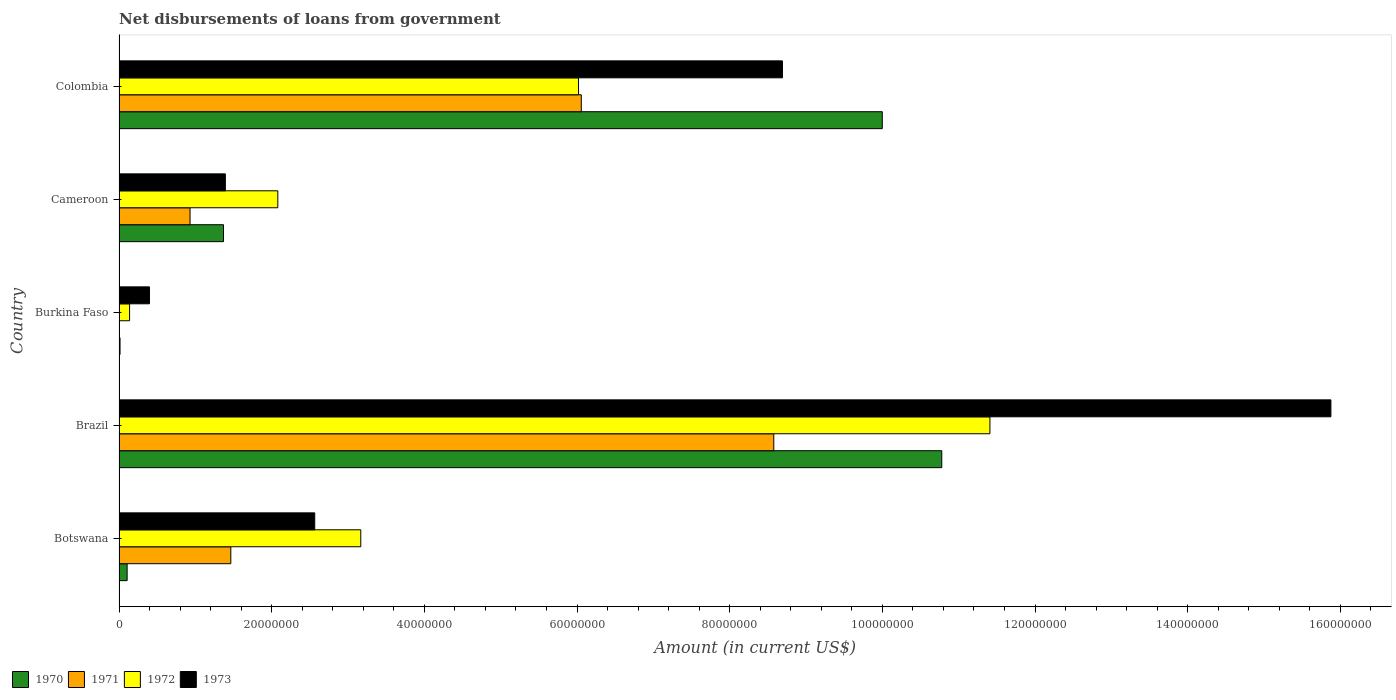How many different coloured bars are there?
Offer a terse response. 4. Are the number of bars per tick equal to the number of legend labels?
Make the answer very short. No. Are the number of bars on each tick of the Y-axis equal?
Your answer should be compact. No. How many bars are there on the 4th tick from the top?
Provide a succinct answer. 4. How many bars are there on the 4th tick from the bottom?
Make the answer very short. 4. What is the label of the 5th group of bars from the top?
Provide a short and direct response. Botswana. In how many cases, is the number of bars for a given country not equal to the number of legend labels?
Your answer should be very brief. 1. What is the amount of loan disbursed from government in 1972 in Burkina Faso?
Give a very brief answer. 1.38e+06. Across all countries, what is the maximum amount of loan disbursed from government in 1973?
Make the answer very short. 1.59e+08. Across all countries, what is the minimum amount of loan disbursed from government in 1972?
Give a very brief answer. 1.38e+06. In which country was the amount of loan disbursed from government in 1972 maximum?
Offer a very short reply. Brazil. What is the total amount of loan disbursed from government in 1973 in the graph?
Keep it short and to the point. 2.89e+08. What is the difference between the amount of loan disbursed from government in 1971 in Botswana and that in Cameroon?
Your answer should be very brief. 5.34e+06. What is the difference between the amount of loan disbursed from government in 1972 in Colombia and the amount of loan disbursed from government in 1970 in Brazil?
Your response must be concise. -4.76e+07. What is the average amount of loan disbursed from government in 1972 per country?
Make the answer very short. 4.56e+07. What is the difference between the amount of loan disbursed from government in 1971 and amount of loan disbursed from government in 1970 in Cameroon?
Provide a succinct answer. -4.38e+06. What is the ratio of the amount of loan disbursed from government in 1972 in Brazil to that in Cameroon?
Give a very brief answer. 5.49. Is the difference between the amount of loan disbursed from government in 1971 in Cameroon and Colombia greater than the difference between the amount of loan disbursed from government in 1970 in Cameroon and Colombia?
Offer a very short reply. Yes. What is the difference between the highest and the second highest amount of loan disbursed from government in 1972?
Your answer should be very brief. 5.39e+07. What is the difference between the highest and the lowest amount of loan disbursed from government in 1971?
Keep it short and to the point. 8.58e+07. In how many countries, is the amount of loan disbursed from government in 1973 greater than the average amount of loan disbursed from government in 1973 taken over all countries?
Offer a very short reply. 2. Is the sum of the amount of loan disbursed from government in 1972 in Brazil and Cameroon greater than the maximum amount of loan disbursed from government in 1973 across all countries?
Provide a succinct answer. No. Is it the case that in every country, the sum of the amount of loan disbursed from government in 1972 and amount of loan disbursed from government in 1970 is greater than the sum of amount of loan disbursed from government in 1971 and amount of loan disbursed from government in 1973?
Provide a short and direct response. No. Is it the case that in every country, the sum of the amount of loan disbursed from government in 1973 and amount of loan disbursed from government in 1970 is greater than the amount of loan disbursed from government in 1971?
Ensure brevity in your answer.  Yes. How many bars are there?
Give a very brief answer. 19. Are all the bars in the graph horizontal?
Keep it short and to the point. Yes. Are the values on the major ticks of X-axis written in scientific E-notation?
Give a very brief answer. No. Does the graph contain any zero values?
Your answer should be compact. Yes. How are the legend labels stacked?
Your response must be concise. Horizontal. What is the title of the graph?
Keep it short and to the point. Net disbursements of loans from government. What is the label or title of the Y-axis?
Offer a terse response. Country. What is the Amount (in current US$) in 1970 in Botswana?
Ensure brevity in your answer.  1.06e+06. What is the Amount (in current US$) in 1971 in Botswana?
Your response must be concise. 1.46e+07. What is the Amount (in current US$) in 1972 in Botswana?
Provide a succinct answer. 3.17e+07. What is the Amount (in current US$) of 1973 in Botswana?
Offer a very short reply. 2.56e+07. What is the Amount (in current US$) in 1970 in Brazil?
Offer a terse response. 1.08e+08. What is the Amount (in current US$) of 1971 in Brazil?
Your answer should be very brief. 8.58e+07. What is the Amount (in current US$) of 1972 in Brazil?
Keep it short and to the point. 1.14e+08. What is the Amount (in current US$) of 1973 in Brazil?
Provide a succinct answer. 1.59e+08. What is the Amount (in current US$) of 1970 in Burkina Faso?
Ensure brevity in your answer.  1.29e+05. What is the Amount (in current US$) of 1971 in Burkina Faso?
Offer a terse response. 0. What is the Amount (in current US$) in 1972 in Burkina Faso?
Give a very brief answer. 1.38e+06. What is the Amount (in current US$) in 1973 in Burkina Faso?
Your answer should be compact. 3.98e+06. What is the Amount (in current US$) of 1970 in Cameroon?
Ensure brevity in your answer.  1.37e+07. What is the Amount (in current US$) of 1971 in Cameroon?
Make the answer very short. 9.30e+06. What is the Amount (in current US$) of 1972 in Cameroon?
Your response must be concise. 2.08e+07. What is the Amount (in current US$) in 1973 in Cameroon?
Offer a very short reply. 1.39e+07. What is the Amount (in current US$) in 1970 in Colombia?
Your response must be concise. 1.00e+08. What is the Amount (in current US$) of 1971 in Colombia?
Offer a very short reply. 6.06e+07. What is the Amount (in current US$) in 1972 in Colombia?
Offer a terse response. 6.02e+07. What is the Amount (in current US$) of 1973 in Colombia?
Make the answer very short. 8.69e+07. Across all countries, what is the maximum Amount (in current US$) of 1970?
Your response must be concise. 1.08e+08. Across all countries, what is the maximum Amount (in current US$) in 1971?
Provide a short and direct response. 8.58e+07. Across all countries, what is the maximum Amount (in current US$) in 1972?
Ensure brevity in your answer.  1.14e+08. Across all countries, what is the maximum Amount (in current US$) of 1973?
Your response must be concise. 1.59e+08. Across all countries, what is the minimum Amount (in current US$) of 1970?
Keep it short and to the point. 1.29e+05. Across all countries, what is the minimum Amount (in current US$) of 1972?
Your answer should be compact. 1.38e+06. Across all countries, what is the minimum Amount (in current US$) in 1973?
Provide a short and direct response. 3.98e+06. What is the total Amount (in current US$) in 1970 in the graph?
Make the answer very short. 2.23e+08. What is the total Amount (in current US$) in 1971 in the graph?
Your answer should be very brief. 1.70e+08. What is the total Amount (in current US$) in 1972 in the graph?
Give a very brief answer. 2.28e+08. What is the total Amount (in current US$) in 1973 in the graph?
Make the answer very short. 2.89e+08. What is the difference between the Amount (in current US$) in 1970 in Botswana and that in Brazil?
Your response must be concise. -1.07e+08. What is the difference between the Amount (in current US$) of 1971 in Botswana and that in Brazil?
Ensure brevity in your answer.  -7.11e+07. What is the difference between the Amount (in current US$) of 1972 in Botswana and that in Brazil?
Your answer should be compact. -8.24e+07. What is the difference between the Amount (in current US$) of 1973 in Botswana and that in Brazil?
Keep it short and to the point. -1.33e+08. What is the difference between the Amount (in current US$) in 1970 in Botswana and that in Burkina Faso?
Make the answer very short. 9.28e+05. What is the difference between the Amount (in current US$) in 1972 in Botswana and that in Burkina Faso?
Give a very brief answer. 3.03e+07. What is the difference between the Amount (in current US$) of 1973 in Botswana and that in Burkina Faso?
Your answer should be compact. 2.17e+07. What is the difference between the Amount (in current US$) of 1970 in Botswana and that in Cameroon?
Offer a terse response. -1.26e+07. What is the difference between the Amount (in current US$) in 1971 in Botswana and that in Cameroon?
Provide a succinct answer. 5.34e+06. What is the difference between the Amount (in current US$) of 1972 in Botswana and that in Cameroon?
Your answer should be compact. 1.09e+07. What is the difference between the Amount (in current US$) in 1973 in Botswana and that in Cameroon?
Provide a succinct answer. 1.17e+07. What is the difference between the Amount (in current US$) of 1970 in Botswana and that in Colombia?
Give a very brief answer. -9.89e+07. What is the difference between the Amount (in current US$) in 1971 in Botswana and that in Colombia?
Provide a succinct answer. -4.59e+07. What is the difference between the Amount (in current US$) of 1972 in Botswana and that in Colombia?
Your answer should be very brief. -2.85e+07. What is the difference between the Amount (in current US$) in 1973 in Botswana and that in Colombia?
Make the answer very short. -6.13e+07. What is the difference between the Amount (in current US$) in 1970 in Brazil and that in Burkina Faso?
Keep it short and to the point. 1.08e+08. What is the difference between the Amount (in current US$) in 1972 in Brazil and that in Burkina Faso?
Provide a succinct answer. 1.13e+08. What is the difference between the Amount (in current US$) in 1973 in Brazil and that in Burkina Faso?
Provide a short and direct response. 1.55e+08. What is the difference between the Amount (in current US$) in 1970 in Brazil and that in Cameroon?
Offer a terse response. 9.41e+07. What is the difference between the Amount (in current US$) in 1971 in Brazil and that in Cameroon?
Your answer should be very brief. 7.65e+07. What is the difference between the Amount (in current US$) in 1972 in Brazil and that in Cameroon?
Offer a terse response. 9.33e+07. What is the difference between the Amount (in current US$) of 1973 in Brazil and that in Cameroon?
Keep it short and to the point. 1.45e+08. What is the difference between the Amount (in current US$) in 1970 in Brazil and that in Colombia?
Provide a short and direct response. 7.79e+06. What is the difference between the Amount (in current US$) in 1971 in Brazil and that in Colombia?
Give a very brief answer. 2.52e+07. What is the difference between the Amount (in current US$) of 1972 in Brazil and that in Colombia?
Keep it short and to the point. 5.39e+07. What is the difference between the Amount (in current US$) in 1973 in Brazil and that in Colombia?
Offer a very short reply. 7.19e+07. What is the difference between the Amount (in current US$) in 1970 in Burkina Faso and that in Cameroon?
Ensure brevity in your answer.  -1.36e+07. What is the difference between the Amount (in current US$) of 1972 in Burkina Faso and that in Cameroon?
Offer a terse response. -1.94e+07. What is the difference between the Amount (in current US$) of 1973 in Burkina Faso and that in Cameroon?
Offer a very short reply. -9.94e+06. What is the difference between the Amount (in current US$) of 1970 in Burkina Faso and that in Colombia?
Provide a succinct answer. -9.99e+07. What is the difference between the Amount (in current US$) of 1972 in Burkina Faso and that in Colombia?
Provide a short and direct response. -5.88e+07. What is the difference between the Amount (in current US$) of 1973 in Burkina Faso and that in Colombia?
Provide a short and direct response. -8.29e+07. What is the difference between the Amount (in current US$) of 1970 in Cameroon and that in Colombia?
Offer a terse response. -8.63e+07. What is the difference between the Amount (in current US$) of 1971 in Cameroon and that in Colombia?
Make the answer very short. -5.13e+07. What is the difference between the Amount (in current US$) in 1972 in Cameroon and that in Colombia?
Give a very brief answer. -3.94e+07. What is the difference between the Amount (in current US$) in 1973 in Cameroon and that in Colombia?
Your response must be concise. -7.30e+07. What is the difference between the Amount (in current US$) of 1970 in Botswana and the Amount (in current US$) of 1971 in Brazil?
Offer a terse response. -8.47e+07. What is the difference between the Amount (in current US$) in 1970 in Botswana and the Amount (in current US$) in 1972 in Brazil?
Your response must be concise. -1.13e+08. What is the difference between the Amount (in current US$) in 1970 in Botswana and the Amount (in current US$) in 1973 in Brazil?
Provide a succinct answer. -1.58e+08. What is the difference between the Amount (in current US$) in 1971 in Botswana and the Amount (in current US$) in 1972 in Brazil?
Make the answer very short. -9.95e+07. What is the difference between the Amount (in current US$) of 1971 in Botswana and the Amount (in current US$) of 1973 in Brazil?
Keep it short and to the point. -1.44e+08. What is the difference between the Amount (in current US$) in 1972 in Botswana and the Amount (in current US$) in 1973 in Brazil?
Your response must be concise. -1.27e+08. What is the difference between the Amount (in current US$) in 1970 in Botswana and the Amount (in current US$) in 1972 in Burkina Faso?
Offer a terse response. -3.23e+05. What is the difference between the Amount (in current US$) in 1970 in Botswana and the Amount (in current US$) in 1973 in Burkina Faso?
Offer a very short reply. -2.93e+06. What is the difference between the Amount (in current US$) of 1971 in Botswana and the Amount (in current US$) of 1972 in Burkina Faso?
Provide a succinct answer. 1.33e+07. What is the difference between the Amount (in current US$) of 1971 in Botswana and the Amount (in current US$) of 1973 in Burkina Faso?
Give a very brief answer. 1.07e+07. What is the difference between the Amount (in current US$) of 1972 in Botswana and the Amount (in current US$) of 1973 in Burkina Faso?
Keep it short and to the point. 2.77e+07. What is the difference between the Amount (in current US$) in 1970 in Botswana and the Amount (in current US$) in 1971 in Cameroon?
Offer a very short reply. -8.24e+06. What is the difference between the Amount (in current US$) of 1970 in Botswana and the Amount (in current US$) of 1972 in Cameroon?
Provide a short and direct response. -1.97e+07. What is the difference between the Amount (in current US$) in 1970 in Botswana and the Amount (in current US$) in 1973 in Cameroon?
Offer a very short reply. -1.29e+07. What is the difference between the Amount (in current US$) in 1971 in Botswana and the Amount (in current US$) in 1972 in Cameroon?
Give a very brief answer. -6.16e+06. What is the difference between the Amount (in current US$) of 1971 in Botswana and the Amount (in current US$) of 1973 in Cameroon?
Ensure brevity in your answer.  7.14e+05. What is the difference between the Amount (in current US$) of 1972 in Botswana and the Amount (in current US$) of 1973 in Cameroon?
Provide a succinct answer. 1.77e+07. What is the difference between the Amount (in current US$) in 1970 in Botswana and the Amount (in current US$) in 1971 in Colombia?
Give a very brief answer. -5.95e+07. What is the difference between the Amount (in current US$) of 1970 in Botswana and the Amount (in current US$) of 1972 in Colombia?
Keep it short and to the point. -5.91e+07. What is the difference between the Amount (in current US$) in 1970 in Botswana and the Amount (in current US$) in 1973 in Colombia?
Provide a succinct answer. -8.59e+07. What is the difference between the Amount (in current US$) of 1971 in Botswana and the Amount (in current US$) of 1972 in Colombia?
Your answer should be compact. -4.56e+07. What is the difference between the Amount (in current US$) in 1971 in Botswana and the Amount (in current US$) in 1973 in Colombia?
Offer a very short reply. -7.23e+07. What is the difference between the Amount (in current US$) in 1972 in Botswana and the Amount (in current US$) in 1973 in Colombia?
Make the answer very short. -5.52e+07. What is the difference between the Amount (in current US$) of 1970 in Brazil and the Amount (in current US$) of 1972 in Burkina Faso?
Your response must be concise. 1.06e+08. What is the difference between the Amount (in current US$) of 1970 in Brazil and the Amount (in current US$) of 1973 in Burkina Faso?
Give a very brief answer. 1.04e+08. What is the difference between the Amount (in current US$) in 1971 in Brazil and the Amount (in current US$) in 1972 in Burkina Faso?
Keep it short and to the point. 8.44e+07. What is the difference between the Amount (in current US$) in 1971 in Brazil and the Amount (in current US$) in 1973 in Burkina Faso?
Your response must be concise. 8.18e+07. What is the difference between the Amount (in current US$) of 1972 in Brazil and the Amount (in current US$) of 1973 in Burkina Faso?
Make the answer very short. 1.10e+08. What is the difference between the Amount (in current US$) in 1970 in Brazil and the Amount (in current US$) in 1971 in Cameroon?
Make the answer very short. 9.85e+07. What is the difference between the Amount (in current US$) of 1970 in Brazil and the Amount (in current US$) of 1972 in Cameroon?
Provide a short and direct response. 8.70e+07. What is the difference between the Amount (in current US$) of 1970 in Brazil and the Amount (in current US$) of 1973 in Cameroon?
Your answer should be very brief. 9.39e+07. What is the difference between the Amount (in current US$) in 1971 in Brazil and the Amount (in current US$) in 1972 in Cameroon?
Keep it short and to the point. 6.50e+07. What is the difference between the Amount (in current US$) in 1971 in Brazil and the Amount (in current US$) in 1973 in Cameroon?
Keep it short and to the point. 7.18e+07. What is the difference between the Amount (in current US$) in 1972 in Brazil and the Amount (in current US$) in 1973 in Cameroon?
Ensure brevity in your answer.  1.00e+08. What is the difference between the Amount (in current US$) in 1970 in Brazil and the Amount (in current US$) in 1971 in Colombia?
Your answer should be compact. 4.72e+07. What is the difference between the Amount (in current US$) in 1970 in Brazil and the Amount (in current US$) in 1972 in Colombia?
Offer a terse response. 4.76e+07. What is the difference between the Amount (in current US$) in 1970 in Brazil and the Amount (in current US$) in 1973 in Colombia?
Your answer should be very brief. 2.09e+07. What is the difference between the Amount (in current US$) in 1971 in Brazil and the Amount (in current US$) in 1972 in Colombia?
Ensure brevity in your answer.  2.56e+07. What is the difference between the Amount (in current US$) in 1971 in Brazil and the Amount (in current US$) in 1973 in Colombia?
Your answer should be very brief. -1.14e+06. What is the difference between the Amount (in current US$) of 1972 in Brazil and the Amount (in current US$) of 1973 in Colombia?
Give a very brief answer. 2.72e+07. What is the difference between the Amount (in current US$) of 1970 in Burkina Faso and the Amount (in current US$) of 1971 in Cameroon?
Offer a terse response. -9.17e+06. What is the difference between the Amount (in current US$) in 1970 in Burkina Faso and the Amount (in current US$) in 1972 in Cameroon?
Your response must be concise. -2.07e+07. What is the difference between the Amount (in current US$) in 1970 in Burkina Faso and the Amount (in current US$) in 1973 in Cameroon?
Offer a very short reply. -1.38e+07. What is the difference between the Amount (in current US$) of 1972 in Burkina Faso and the Amount (in current US$) of 1973 in Cameroon?
Provide a short and direct response. -1.25e+07. What is the difference between the Amount (in current US$) of 1970 in Burkina Faso and the Amount (in current US$) of 1971 in Colombia?
Your answer should be compact. -6.04e+07. What is the difference between the Amount (in current US$) of 1970 in Burkina Faso and the Amount (in current US$) of 1972 in Colombia?
Make the answer very short. -6.01e+07. What is the difference between the Amount (in current US$) of 1970 in Burkina Faso and the Amount (in current US$) of 1973 in Colombia?
Your response must be concise. -8.68e+07. What is the difference between the Amount (in current US$) of 1972 in Burkina Faso and the Amount (in current US$) of 1973 in Colombia?
Your answer should be very brief. -8.55e+07. What is the difference between the Amount (in current US$) of 1970 in Cameroon and the Amount (in current US$) of 1971 in Colombia?
Keep it short and to the point. -4.69e+07. What is the difference between the Amount (in current US$) in 1970 in Cameroon and the Amount (in current US$) in 1972 in Colombia?
Provide a succinct answer. -4.65e+07. What is the difference between the Amount (in current US$) of 1970 in Cameroon and the Amount (in current US$) of 1973 in Colombia?
Provide a short and direct response. -7.32e+07. What is the difference between the Amount (in current US$) in 1971 in Cameroon and the Amount (in current US$) in 1972 in Colombia?
Provide a succinct answer. -5.09e+07. What is the difference between the Amount (in current US$) in 1971 in Cameroon and the Amount (in current US$) in 1973 in Colombia?
Keep it short and to the point. -7.76e+07. What is the difference between the Amount (in current US$) in 1972 in Cameroon and the Amount (in current US$) in 1973 in Colombia?
Ensure brevity in your answer.  -6.61e+07. What is the average Amount (in current US$) in 1970 per country?
Offer a terse response. 4.45e+07. What is the average Amount (in current US$) of 1971 per country?
Offer a very short reply. 3.41e+07. What is the average Amount (in current US$) in 1972 per country?
Offer a very short reply. 4.56e+07. What is the average Amount (in current US$) in 1973 per country?
Make the answer very short. 5.78e+07. What is the difference between the Amount (in current US$) of 1970 and Amount (in current US$) of 1971 in Botswana?
Give a very brief answer. -1.36e+07. What is the difference between the Amount (in current US$) of 1970 and Amount (in current US$) of 1972 in Botswana?
Offer a terse response. -3.06e+07. What is the difference between the Amount (in current US$) of 1970 and Amount (in current US$) of 1973 in Botswana?
Offer a very short reply. -2.46e+07. What is the difference between the Amount (in current US$) of 1971 and Amount (in current US$) of 1972 in Botswana?
Make the answer very short. -1.70e+07. What is the difference between the Amount (in current US$) in 1971 and Amount (in current US$) in 1973 in Botswana?
Provide a succinct answer. -1.10e+07. What is the difference between the Amount (in current US$) in 1972 and Amount (in current US$) in 1973 in Botswana?
Keep it short and to the point. 6.03e+06. What is the difference between the Amount (in current US$) of 1970 and Amount (in current US$) of 1971 in Brazil?
Make the answer very short. 2.20e+07. What is the difference between the Amount (in current US$) in 1970 and Amount (in current US$) in 1972 in Brazil?
Your response must be concise. -6.31e+06. What is the difference between the Amount (in current US$) of 1970 and Amount (in current US$) of 1973 in Brazil?
Make the answer very short. -5.10e+07. What is the difference between the Amount (in current US$) in 1971 and Amount (in current US$) in 1972 in Brazil?
Your answer should be very brief. -2.83e+07. What is the difference between the Amount (in current US$) in 1971 and Amount (in current US$) in 1973 in Brazil?
Your answer should be very brief. -7.30e+07. What is the difference between the Amount (in current US$) in 1972 and Amount (in current US$) in 1973 in Brazil?
Give a very brief answer. -4.47e+07. What is the difference between the Amount (in current US$) of 1970 and Amount (in current US$) of 1972 in Burkina Faso?
Ensure brevity in your answer.  -1.25e+06. What is the difference between the Amount (in current US$) in 1970 and Amount (in current US$) in 1973 in Burkina Faso?
Ensure brevity in your answer.  -3.86e+06. What is the difference between the Amount (in current US$) of 1972 and Amount (in current US$) of 1973 in Burkina Faso?
Keep it short and to the point. -2.60e+06. What is the difference between the Amount (in current US$) in 1970 and Amount (in current US$) in 1971 in Cameroon?
Provide a short and direct response. 4.38e+06. What is the difference between the Amount (in current US$) in 1970 and Amount (in current US$) in 1972 in Cameroon?
Give a very brief answer. -7.12e+06. What is the difference between the Amount (in current US$) of 1970 and Amount (in current US$) of 1973 in Cameroon?
Provide a succinct answer. -2.45e+05. What is the difference between the Amount (in current US$) in 1971 and Amount (in current US$) in 1972 in Cameroon?
Provide a succinct answer. -1.15e+07. What is the difference between the Amount (in current US$) in 1971 and Amount (in current US$) in 1973 in Cameroon?
Your answer should be very brief. -4.63e+06. What is the difference between the Amount (in current US$) of 1972 and Amount (in current US$) of 1973 in Cameroon?
Ensure brevity in your answer.  6.87e+06. What is the difference between the Amount (in current US$) of 1970 and Amount (in current US$) of 1971 in Colombia?
Give a very brief answer. 3.94e+07. What is the difference between the Amount (in current US$) of 1970 and Amount (in current US$) of 1972 in Colombia?
Your answer should be very brief. 3.98e+07. What is the difference between the Amount (in current US$) of 1970 and Amount (in current US$) of 1973 in Colombia?
Your response must be concise. 1.31e+07. What is the difference between the Amount (in current US$) of 1971 and Amount (in current US$) of 1972 in Colombia?
Offer a very short reply. 3.62e+05. What is the difference between the Amount (in current US$) in 1971 and Amount (in current US$) in 1973 in Colombia?
Your response must be concise. -2.64e+07. What is the difference between the Amount (in current US$) in 1972 and Amount (in current US$) in 1973 in Colombia?
Offer a terse response. -2.67e+07. What is the ratio of the Amount (in current US$) in 1970 in Botswana to that in Brazil?
Your response must be concise. 0.01. What is the ratio of the Amount (in current US$) of 1971 in Botswana to that in Brazil?
Make the answer very short. 0.17. What is the ratio of the Amount (in current US$) of 1972 in Botswana to that in Brazil?
Your answer should be very brief. 0.28. What is the ratio of the Amount (in current US$) in 1973 in Botswana to that in Brazil?
Provide a succinct answer. 0.16. What is the ratio of the Amount (in current US$) of 1970 in Botswana to that in Burkina Faso?
Your answer should be very brief. 8.19. What is the ratio of the Amount (in current US$) in 1972 in Botswana to that in Burkina Faso?
Give a very brief answer. 22.95. What is the ratio of the Amount (in current US$) in 1973 in Botswana to that in Burkina Faso?
Make the answer very short. 6.43. What is the ratio of the Amount (in current US$) of 1970 in Botswana to that in Cameroon?
Provide a succinct answer. 0.08. What is the ratio of the Amount (in current US$) in 1971 in Botswana to that in Cameroon?
Your answer should be very brief. 1.57. What is the ratio of the Amount (in current US$) in 1972 in Botswana to that in Cameroon?
Give a very brief answer. 1.52. What is the ratio of the Amount (in current US$) in 1973 in Botswana to that in Cameroon?
Your response must be concise. 1.84. What is the ratio of the Amount (in current US$) in 1970 in Botswana to that in Colombia?
Keep it short and to the point. 0.01. What is the ratio of the Amount (in current US$) in 1971 in Botswana to that in Colombia?
Your answer should be compact. 0.24. What is the ratio of the Amount (in current US$) in 1972 in Botswana to that in Colombia?
Ensure brevity in your answer.  0.53. What is the ratio of the Amount (in current US$) in 1973 in Botswana to that in Colombia?
Offer a very short reply. 0.29. What is the ratio of the Amount (in current US$) of 1970 in Brazil to that in Burkina Faso?
Offer a very short reply. 835.53. What is the ratio of the Amount (in current US$) of 1972 in Brazil to that in Burkina Faso?
Provide a succinct answer. 82.68. What is the ratio of the Amount (in current US$) in 1973 in Brazil to that in Burkina Faso?
Offer a very short reply. 39.84. What is the ratio of the Amount (in current US$) in 1970 in Brazil to that in Cameroon?
Offer a terse response. 7.88. What is the ratio of the Amount (in current US$) in 1971 in Brazil to that in Cameroon?
Your answer should be very brief. 9.22. What is the ratio of the Amount (in current US$) in 1972 in Brazil to that in Cameroon?
Offer a very short reply. 5.49. What is the ratio of the Amount (in current US$) in 1973 in Brazil to that in Cameroon?
Ensure brevity in your answer.  11.4. What is the ratio of the Amount (in current US$) in 1970 in Brazil to that in Colombia?
Keep it short and to the point. 1.08. What is the ratio of the Amount (in current US$) of 1971 in Brazil to that in Colombia?
Make the answer very short. 1.42. What is the ratio of the Amount (in current US$) of 1972 in Brazil to that in Colombia?
Provide a short and direct response. 1.9. What is the ratio of the Amount (in current US$) in 1973 in Brazil to that in Colombia?
Your response must be concise. 1.83. What is the ratio of the Amount (in current US$) in 1970 in Burkina Faso to that in Cameroon?
Give a very brief answer. 0.01. What is the ratio of the Amount (in current US$) in 1972 in Burkina Faso to that in Cameroon?
Make the answer very short. 0.07. What is the ratio of the Amount (in current US$) of 1973 in Burkina Faso to that in Cameroon?
Your answer should be compact. 0.29. What is the ratio of the Amount (in current US$) in 1970 in Burkina Faso to that in Colombia?
Make the answer very short. 0. What is the ratio of the Amount (in current US$) in 1972 in Burkina Faso to that in Colombia?
Provide a short and direct response. 0.02. What is the ratio of the Amount (in current US$) in 1973 in Burkina Faso to that in Colombia?
Make the answer very short. 0.05. What is the ratio of the Amount (in current US$) in 1970 in Cameroon to that in Colombia?
Provide a succinct answer. 0.14. What is the ratio of the Amount (in current US$) in 1971 in Cameroon to that in Colombia?
Offer a very short reply. 0.15. What is the ratio of the Amount (in current US$) of 1972 in Cameroon to that in Colombia?
Your answer should be very brief. 0.35. What is the ratio of the Amount (in current US$) of 1973 in Cameroon to that in Colombia?
Ensure brevity in your answer.  0.16. What is the difference between the highest and the second highest Amount (in current US$) in 1970?
Provide a short and direct response. 7.79e+06. What is the difference between the highest and the second highest Amount (in current US$) of 1971?
Your response must be concise. 2.52e+07. What is the difference between the highest and the second highest Amount (in current US$) of 1972?
Ensure brevity in your answer.  5.39e+07. What is the difference between the highest and the second highest Amount (in current US$) in 1973?
Your response must be concise. 7.19e+07. What is the difference between the highest and the lowest Amount (in current US$) of 1970?
Provide a succinct answer. 1.08e+08. What is the difference between the highest and the lowest Amount (in current US$) of 1971?
Ensure brevity in your answer.  8.58e+07. What is the difference between the highest and the lowest Amount (in current US$) in 1972?
Offer a very short reply. 1.13e+08. What is the difference between the highest and the lowest Amount (in current US$) of 1973?
Offer a terse response. 1.55e+08. 